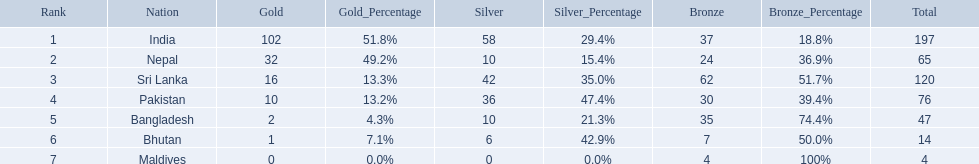What are the nations? India, Nepal, Sri Lanka, Pakistan, Bangladesh, Bhutan, Maldives. Of these, which one has earned the least amount of gold medals? Maldives. 